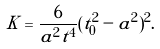Convert formula to latex. <formula><loc_0><loc_0><loc_500><loc_500>K = \frac { 6 } { a ^ { 2 } t ^ { 4 } } ( t ^ { 2 } _ { 0 } - a ^ { 2 } ) ^ { 2 } .</formula> 